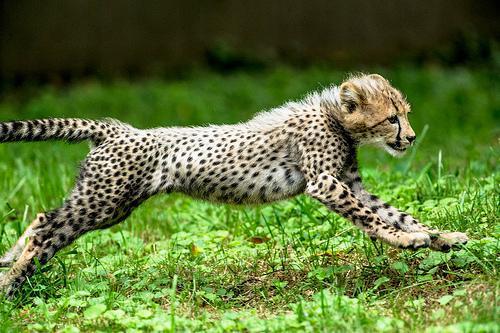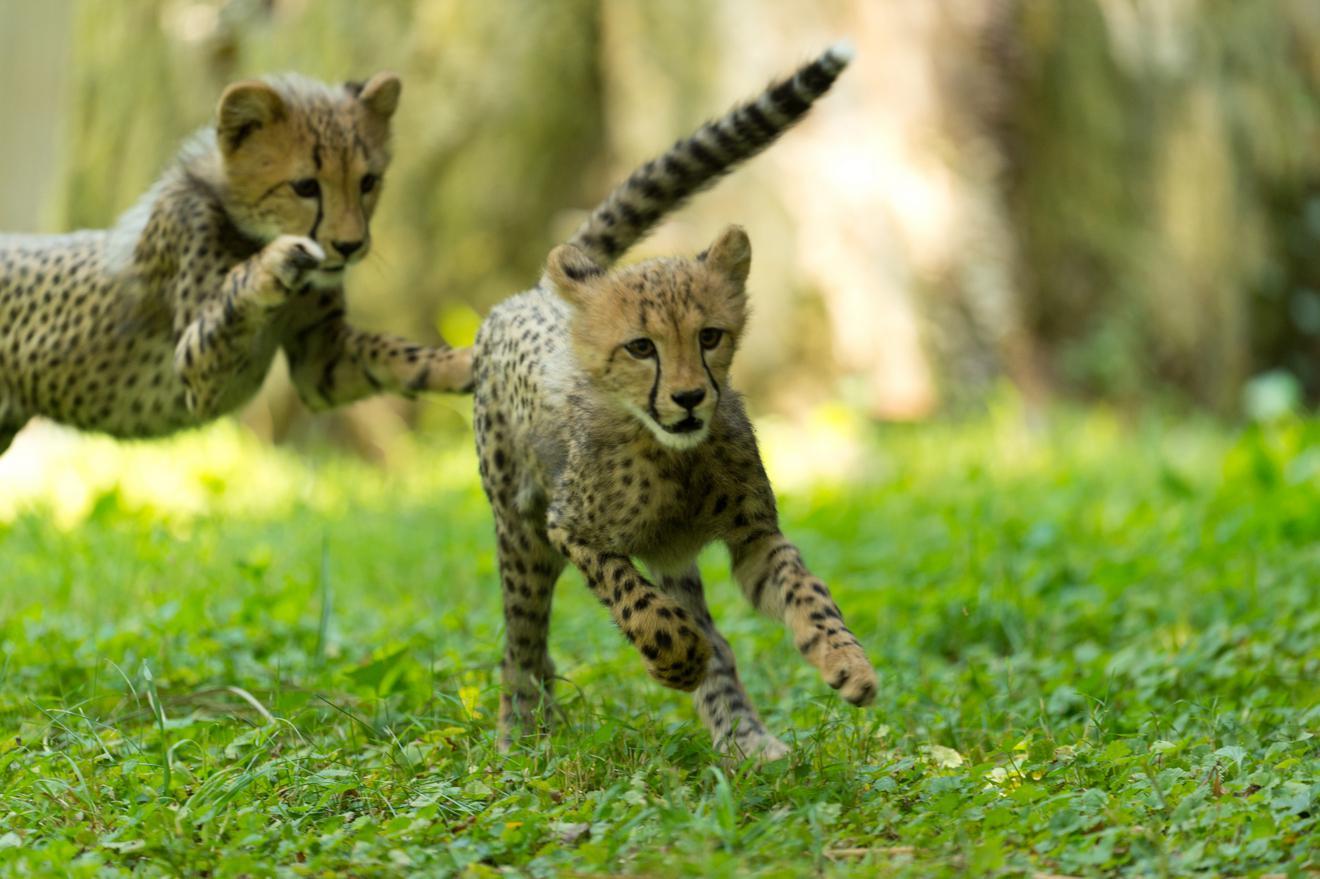The first image is the image on the left, the second image is the image on the right. Given the left and right images, does the statement "There are two cheetahs fighting with one of the cheetahs on its backside." hold true? Answer yes or no. No. The first image is the image on the left, the second image is the image on the right. For the images shown, is this caption "There is a single cheetah in the left image and two cheetahs in the right image." true? Answer yes or no. Yes. 